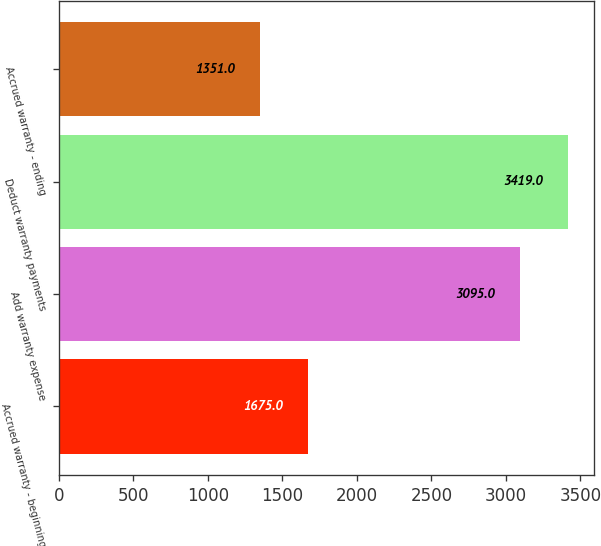Convert chart. <chart><loc_0><loc_0><loc_500><loc_500><bar_chart><fcel>Accrued warranty - beginning<fcel>Add warranty expense<fcel>Deduct warranty payments<fcel>Accrued warranty - ending<nl><fcel>1675<fcel>3095<fcel>3419<fcel>1351<nl></chart> 